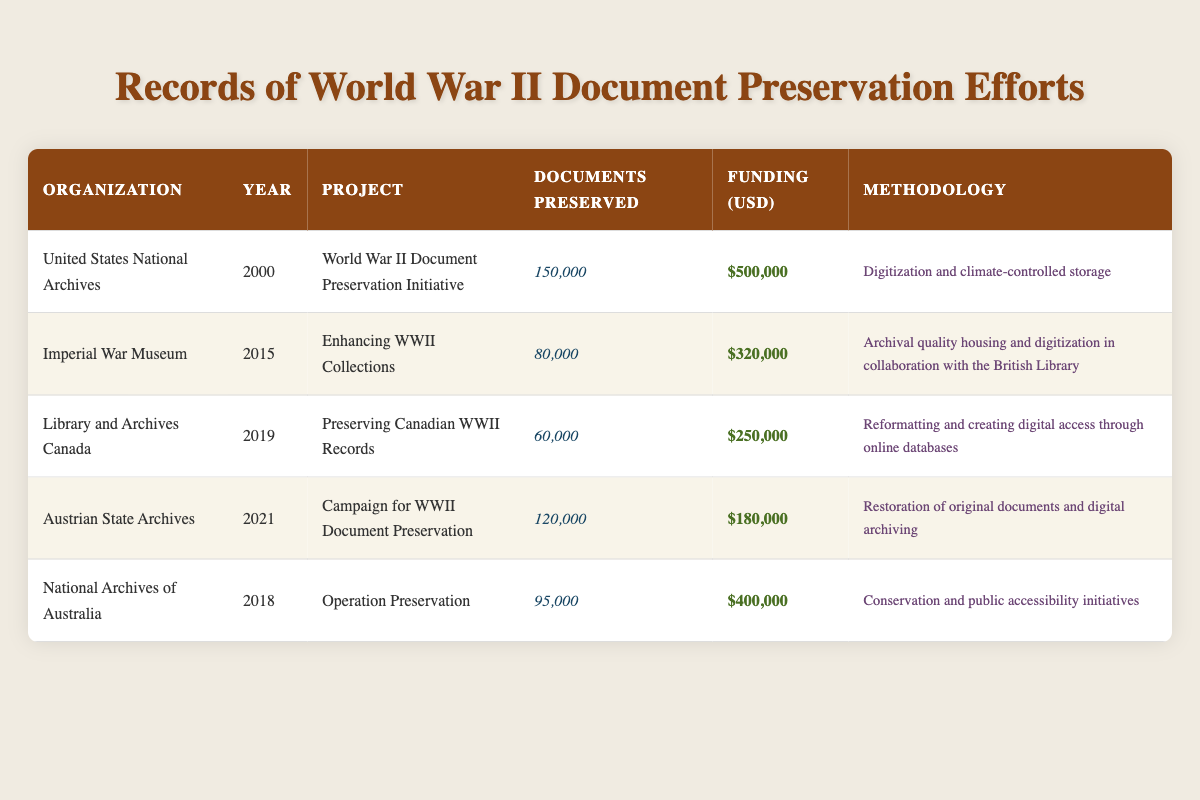What organization initiated the World War II Document Preservation Initiative? The table lists that the United States National Archives initiated the World War II Document Preservation Initiative in the year 2000.
Answer: United States National Archives How much funding was allocated for the Enhancing WWII Collections project? According to the table, the Enhancing WWII Collections project, conducted by the Imperial War Museum in 2015, received funding of $320,000.
Answer: $320,000 What is the total number of documents preserved across all projects in the table? To find the total, we need to add the documents preserved for each project: 150,000 + 80,000 + 60,000 + 120,000 + 95,000 = 505,000.
Answer: 505,000 Which project had the highest number of documents preserved? By examining the documents preserved column, the World War II Document Preservation Initiative by the United States National Archives in 2000 preserved the highest amount, which is 150,000 documents.
Answer: 150,000 Is the methodology for preserving Canadian WWII records focused on physical restoration? The methodology for the project Preserving Canadian WWII Records by Library and Archives Canada is about reformatting and creating digital access, which indicates it is not focused on physical restoration. Therefore, the answer is false.
Answer: No Which organization had the least funding for their preservation project? Upon reviewing the funding amounts, the Austrian State Archives had the least funding for their project, which was $180,000 for the Campaign for WWII Document Preservation in 2021.
Answer: $180,000 What was the average funding amount allocated to the projects listed in the table? To calculate the average funding, we sum the funding amounts: 500,000 + 320,000 + 250,000 + 180,000 + 400,000 = 1,650,000. Since there are 5 projects, we divide by 5: 1,650,000 / 5 = 330,000.
Answer: $330,000 Which two organizations focused on digitization as part of their preservation methodology? From the table, the United States National Archives and the Imperial War Museum both included digitization in their methodologies for their respective projects.
Answer: United States National Archives and Imperial War Museum Did the National Archives of Australia preserve more documents than the Library and Archives Canada? The National Archives of Australia preserved 95,000 documents, while the Library and Archives Canada preserved 60,000 documents, which indicates that the National Archives of Australia did preserve more documents. Therefore, the answer is yes.
Answer: Yes 